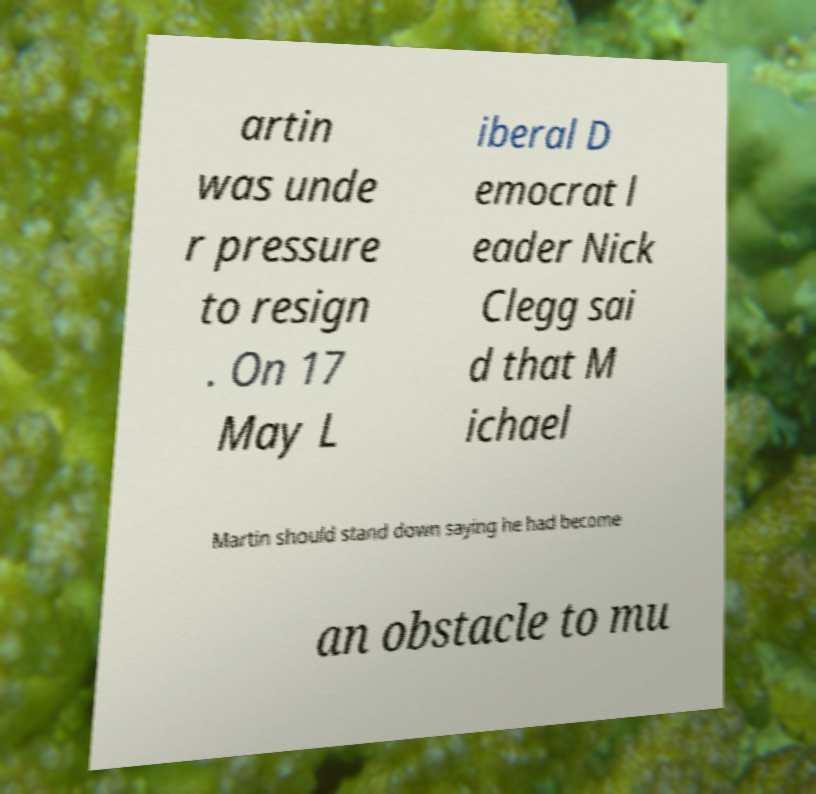There's text embedded in this image that I need extracted. Can you transcribe it verbatim? artin was unde r pressure to resign . On 17 May L iberal D emocrat l eader Nick Clegg sai d that M ichael Martin should stand down saying he had become an obstacle to mu 